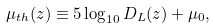<formula> <loc_0><loc_0><loc_500><loc_500>\mu _ { t h } ( z ) \equiv 5 \log _ { 1 0 } D _ { L } ( z ) + \mu _ { 0 } ,</formula> 